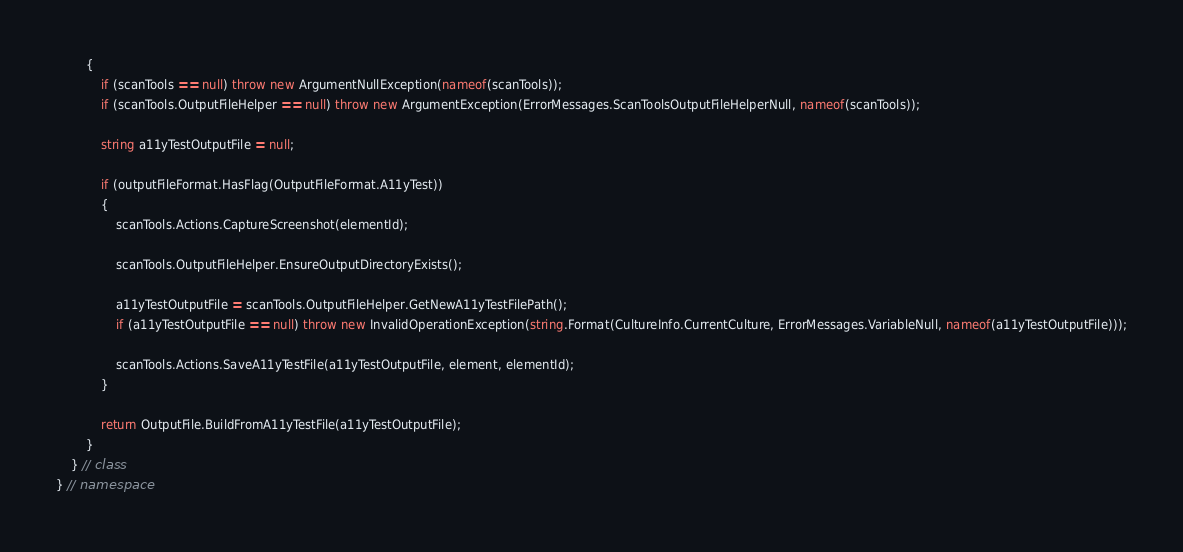<code> <loc_0><loc_0><loc_500><loc_500><_C#_>        {
            if (scanTools == null) throw new ArgumentNullException(nameof(scanTools));
            if (scanTools.OutputFileHelper == null) throw new ArgumentException(ErrorMessages.ScanToolsOutputFileHelperNull, nameof(scanTools));

            string a11yTestOutputFile = null;

            if (outputFileFormat.HasFlag(OutputFileFormat.A11yTest))
            {
                scanTools.Actions.CaptureScreenshot(elementId);

                scanTools.OutputFileHelper.EnsureOutputDirectoryExists();

                a11yTestOutputFile = scanTools.OutputFileHelper.GetNewA11yTestFilePath();
                if (a11yTestOutputFile == null) throw new InvalidOperationException(string.Format(CultureInfo.CurrentCulture, ErrorMessages.VariableNull, nameof(a11yTestOutputFile)));

                scanTools.Actions.SaveA11yTestFile(a11yTestOutputFile, element, elementId);
            }

            return OutputFile.BuildFromA11yTestFile(a11yTestOutputFile);
        }
    } // class
} // namespace
</code> 